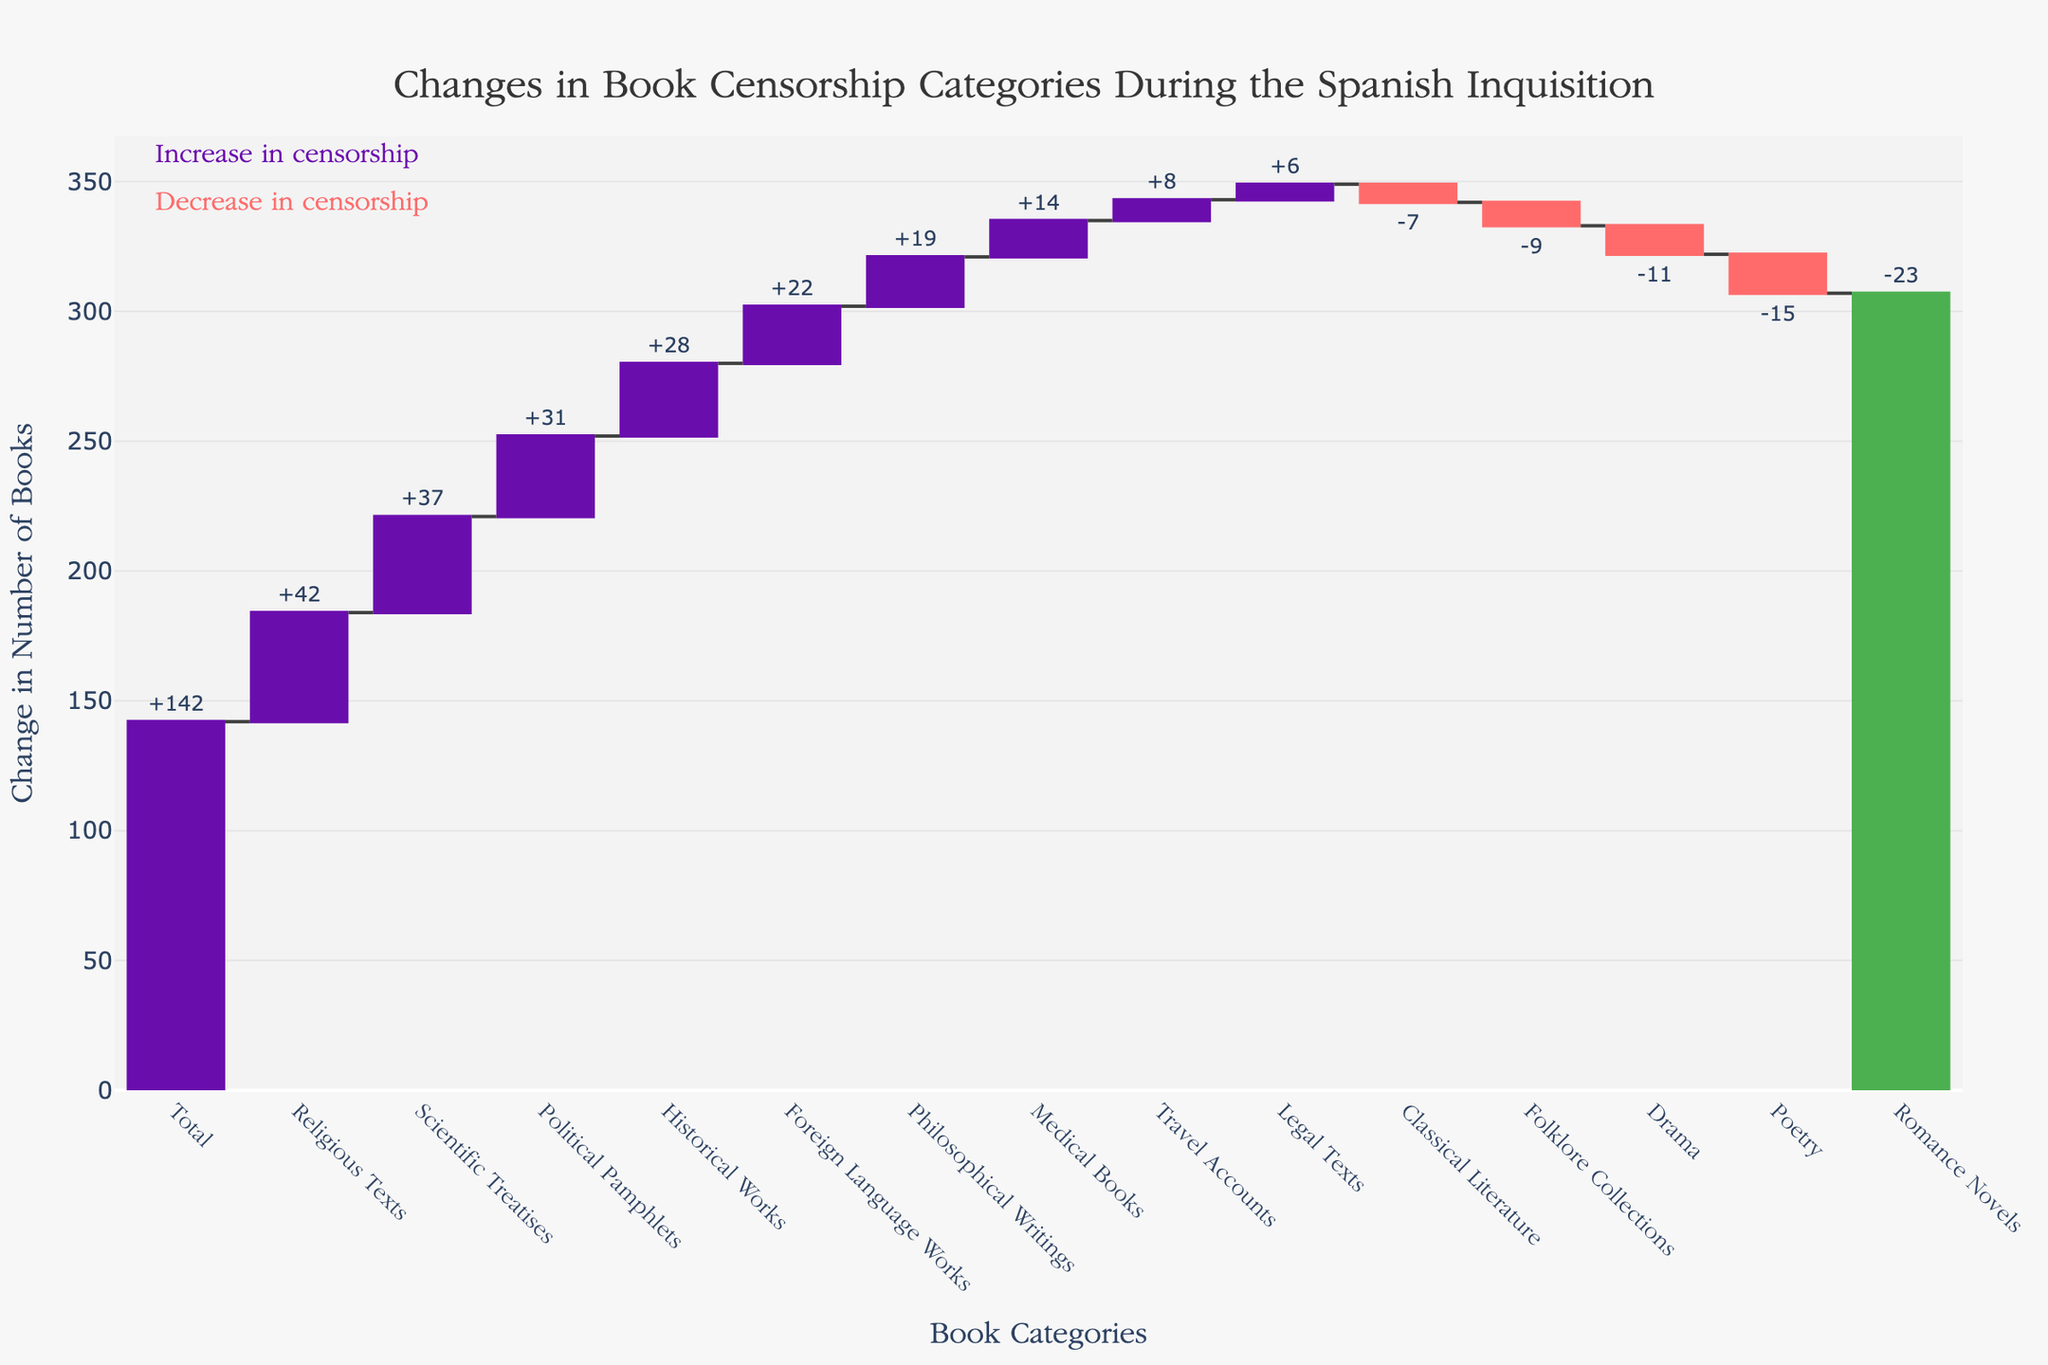what's the title of the figure? The title is displayed prominently at the top of the chart. Reading directly from the chart, the title is "Changes in Book Censorship Categories During the Spanish Inquisition".
Answer: Changes in Book Censorship Categories During the Spanish Inquisition Which category experienced the highest increase in censorship? To determine this, look for the highest bar above the zero line in the chart. The bar labeled "Religious Texts" is the tallest among those bars, indicating the highest increase in censorship.
Answer: Religious Texts What is the total change in book censorship? The total change in book censorship is indicated by the last bar in the waterfall chart usually marked as "Total". The figure clearly shows "+142" as the total change.
Answer: +142 Which category had the most significant reduction in censorship? Identify the lowest bar below the zero line on the chart. The bar labeled "Romance Novels" is the most substantial among the negative changes, signifying the most significant reduction.
Answer: Romance Novels How many categories saw a decrease in censorship? Count the number of bars below the zero line. The categories "Poetry," "Romance Novels," "Classical Literature," "Drama," and "Folklore Collections" represent decreases. There are 5 such categories in total.
Answer: 5 What is the net change in censorship for "Scientific Treatises" and "Political Pamphlets"? To find the net change, sum the changes for "Scientific Treatises" (+37) and "Political Pamphlets" (+31). The net change is 37 + 31 = 68.
Answer: +68 Between "Philosophical Writings" and "Historical Works," which one experienced a greater change in censorship, and what is the difference? Compare the values of changes for both categories. "Philosophical Writings" increased by +19 and "Historical Works" increased by +28. Thus, "Historical Works" experienced a greater change. The difference is 28 - 19 = 9.
Answer: Historical Works, 9 What is the average change in censorship for the categories with positive changes? First, list all positive change values: +42, +28, +37, +19, +8, +31, +14, +22, +6. Then sum these changes which equals 207. Divide this sum by the number of positive change categories (9) for the average: 207 / 9 ≈ 23.
Answer: ≈ 23 How does the change in "Foreign Language Works" compare to "Medical Books"? To compare, note the values: "Foreign Language Works" increased by +22, while "Medical Books" increased by +14. The change in "Foreign Language Works" is greater by 22 - 14 = 8.
Answer: Greater by 8 What color represents the bars with decreased censorship? According to the chart, bars with decreased censorship are color-coded. The color of these bars is generally red in the chart.
Answer: Red 